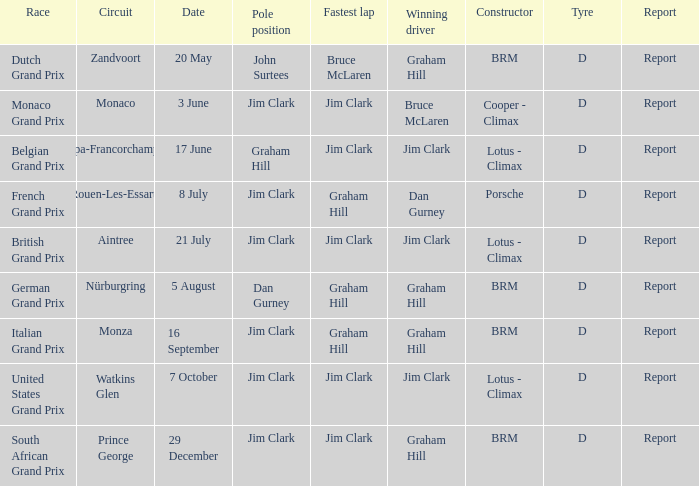What is the date of the circuit of Monaco? 3 June. 